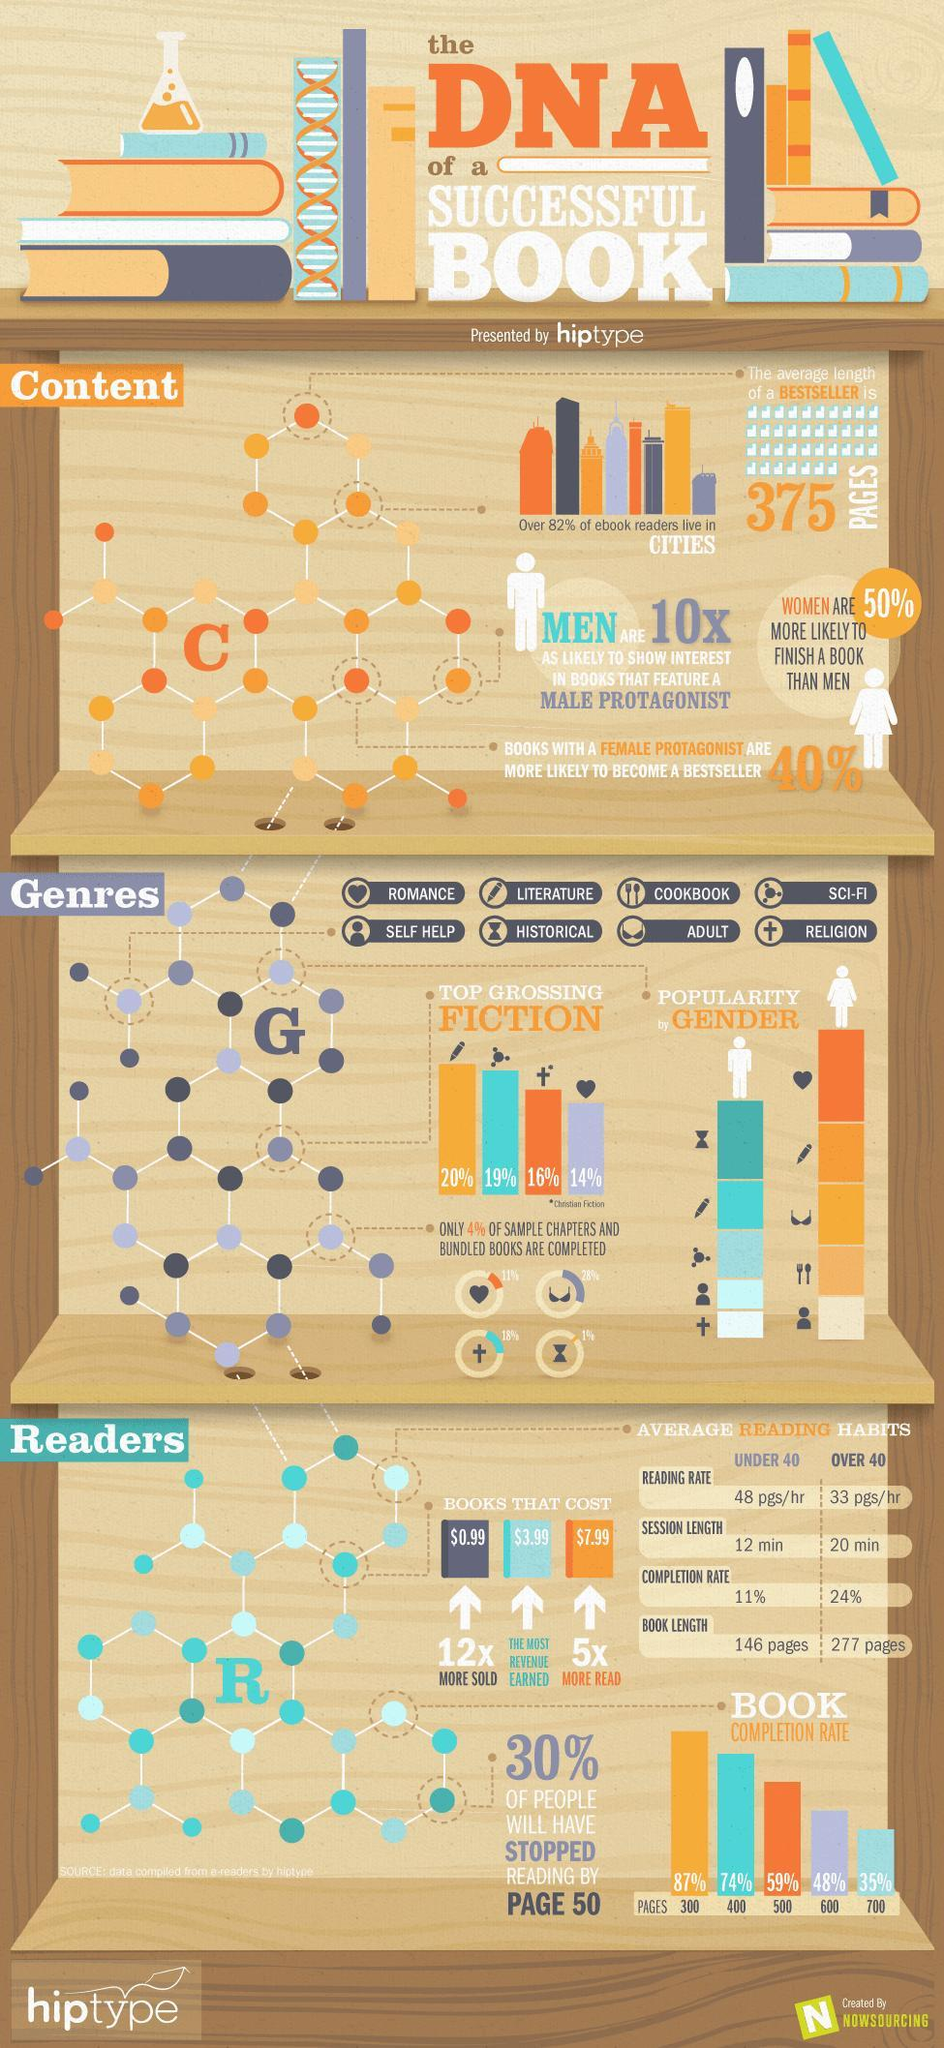Which is the least popular genre among men?
Answer the question with a short phrase. RELIGION Which genre is read by 19% of people? SCI-FI What does cross symbol denote? RELIGION What percent of people will finish a book of 600 pages? 48% Which genre is represented by heart symbol? ROMANCE By what rate is completion of books greater in those over 40 than under 40? 13% Which is the most preferred genre among women? ROMANCE Which is the most preferred genre among men? HISTORICAL Which is the least popular genre among women? SELF HELP Which genre is first among top grossing fiction? LITERATURE By what symbol is historical genre represented- cross, hourglass or heart? hourglass Who reads more pages on average- under 40 or over 40? OVER 40 Which genre corresponds to 14% of top grossing fiction? ROMANCE What is the average length of the bestseller? 375 PAGES What percent of top grossing fiction is religion? 16% 